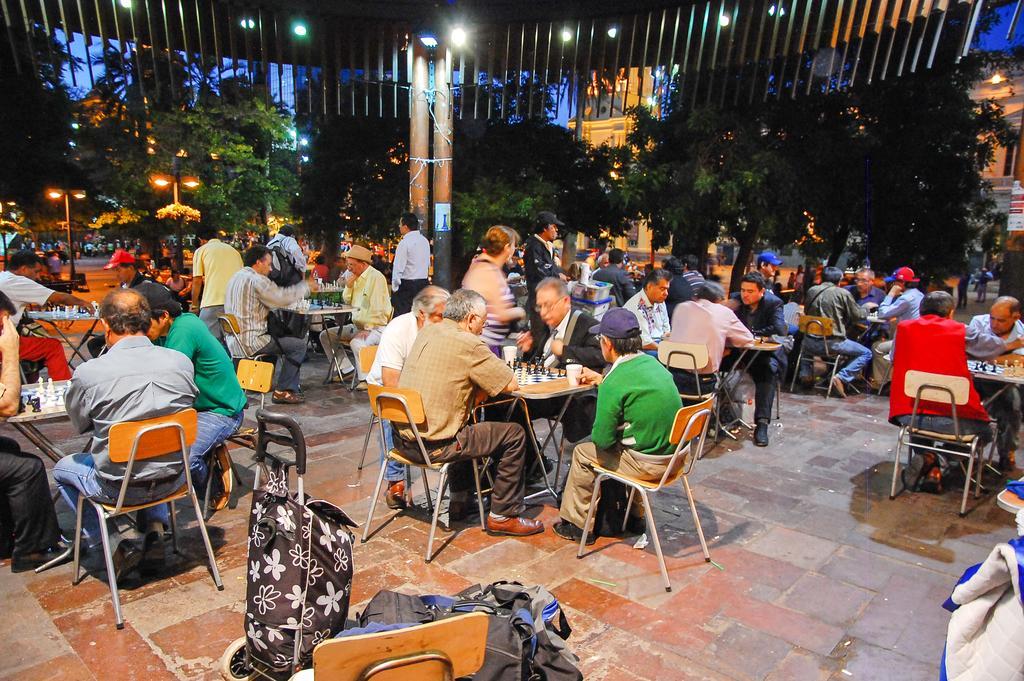Could you give a brief overview of what you see in this image? Here we can see group of papers sitting on chairs with tables in front of them, all of them are playing chess and behind them we can see light posts, trees and buildings present 